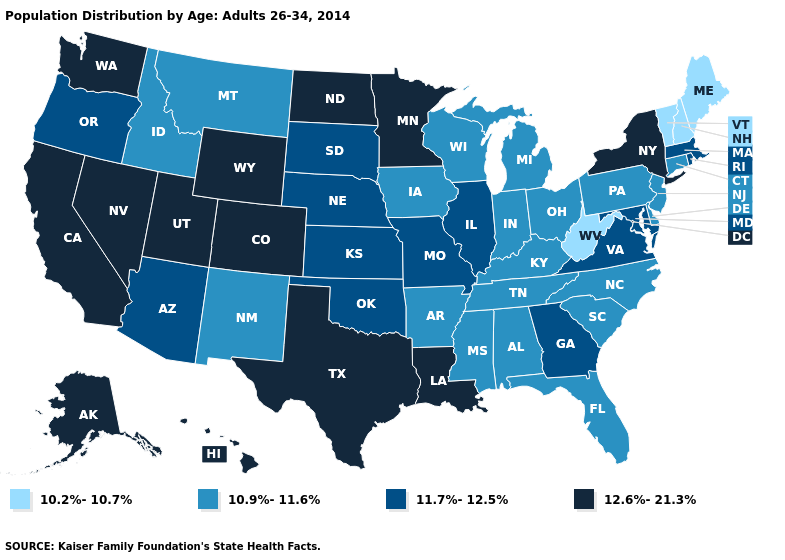Does Texas have the same value as Kentucky?
Answer briefly. No. What is the value of North Dakota?
Answer briefly. 12.6%-21.3%. Name the states that have a value in the range 11.7%-12.5%?
Write a very short answer. Arizona, Georgia, Illinois, Kansas, Maryland, Massachusetts, Missouri, Nebraska, Oklahoma, Oregon, Rhode Island, South Dakota, Virginia. Is the legend a continuous bar?
Short answer required. No. Name the states that have a value in the range 11.7%-12.5%?
Quick response, please. Arizona, Georgia, Illinois, Kansas, Maryland, Massachusetts, Missouri, Nebraska, Oklahoma, Oregon, Rhode Island, South Dakota, Virginia. Does Illinois have the highest value in the USA?
Quick response, please. No. What is the lowest value in the USA?
Quick response, please. 10.2%-10.7%. What is the lowest value in the West?
Keep it brief. 10.9%-11.6%. Among the states that border Wyoming , does Montana have the lowest value?
Concise answer only. Yes. What is the highest value in the USA?
Concise answer only. 12.6%-21.3%. What is the value of Oregon?
Be succinct. 11.7%-12.5%. Name the states that have a value in the range 11.7%-12.5%?
Short answer required. Arizona, Georgia, Illinois, Kansas, Maryland, Massachusetts, Missouri, Nebraska, Oklahoma, Oregon, Rhode Island, South Dakota, Virginia. What is the lowest value in states that border Georgia?
Write a very short answer. 10.9%-11.6%. What is the value of South Dakota?
Answer briefly. 11.7%-12.5%. What is the value of Iowa?
Write a very short answer. 10.9%-11.6%. 